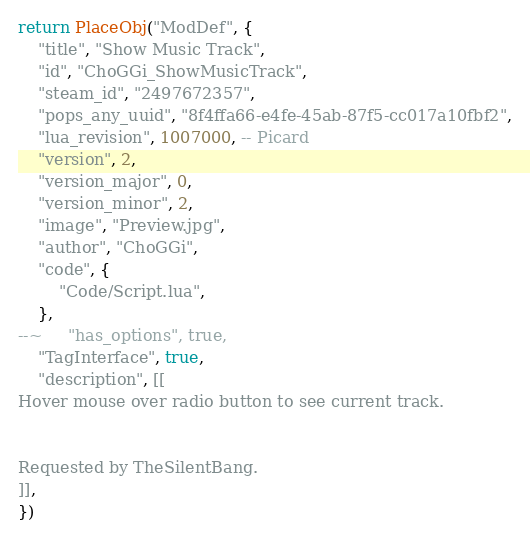Convert code to text. <code><loc_0><loc_0><loc_500><loc_500><_Lua_>return PlaceObj("ModDef", {
	"title", "Show Music Track",
	"id", "ChoGGi_ShowMusicTrack",
	"steam_id", "2497672357",
	"pops_any_uuid", "8f4ffa66-e4fe-45ab-87f5-cc017a10fbf2",
	"lua_revision", 1007000, -- Picard
	"version", 2,
	"version_major", 0,
	"version_minor", 2,
	"image", "Preview.jpg",
	"author", "ChoGGi",
	"code", {
		"Code/Script.lua",
	},
--~ 	"has_options", true,
	"TagInterface", true,
	"description", [[
Hover mouse over radio button to see current track.


Requested by TheSilentBang.
]],
})
</code> 